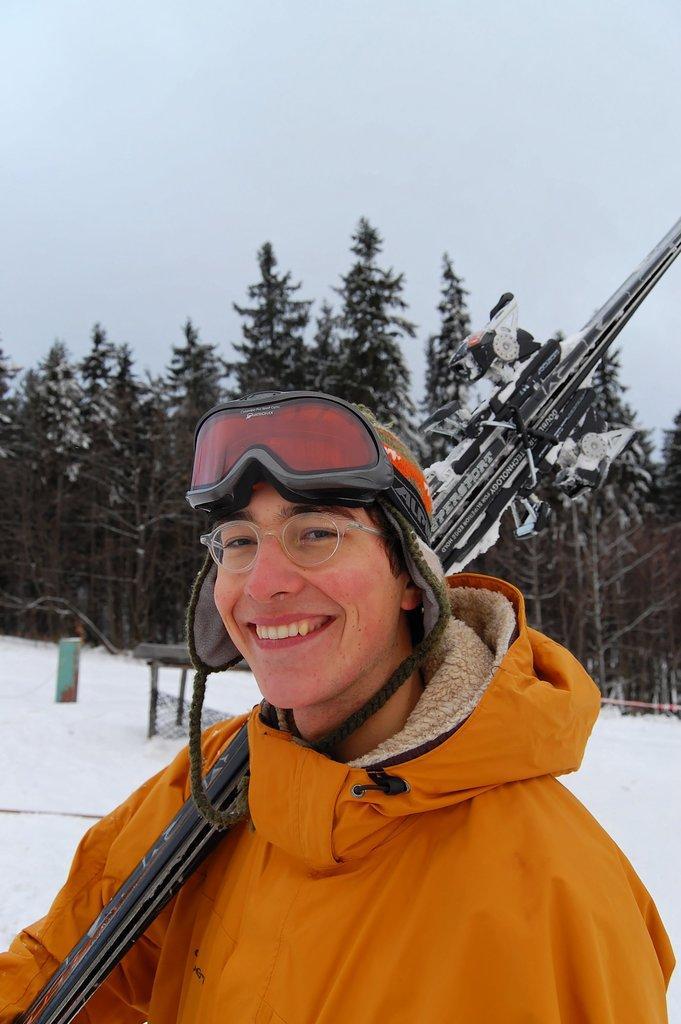Can you describe this image briefly? In this image we can see a person smiling and holding a ski board. In the background there are trees, snow and sky. 